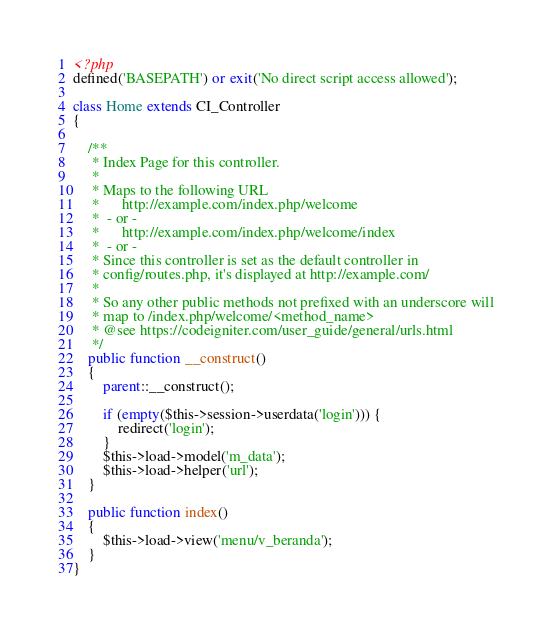Convert code to text. <code><loc_0><loc_0><loc_500><loc_500><_PHP_><?php
defined('BASEPATH') or exit('No direct script access allowed');

class Home extends CI_Controller
{

	/**
	 * Index Page for this controller.
	 *
	 * Maps to the following URL
	 * 		http://example.com/index.php/welcome
	 *	- or -
	 * 		http://example.com/index.php/welcome/index
	 *	- or -
	 * Since this controller is set as the default controller in
	 * config/routes.php, it's displayed at http://example.com/
	 *
	 * So any other public methods not prefixed with an underscore will
	 * map to /index.php/welcome/<method_name>
	 * @see https://codeigniter.com/user_guide/general/urls.html
	 */
	public function __construct()
	{
		parent::__construct();

		if (empty($this->session->userdata('login'))) {
			redirect('login');
		}
		$this->load->model('m_data');
		$this->load->helper('url');
	}

	public function index()
	{
		$this->load->view('menu/v_beranda');
	}
}
</code> 